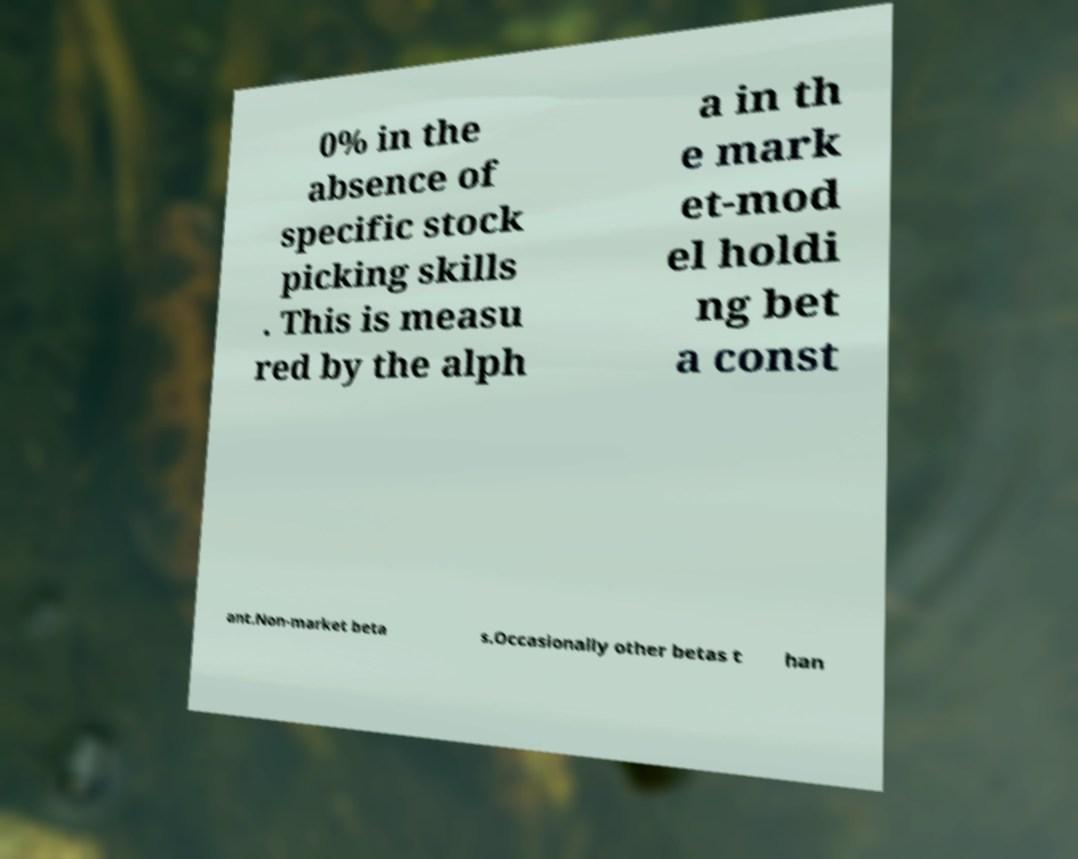Could you assist in decoding the text presented in this image and type it out clearly? 0% in the absence of specific stock picking skills . This is measu red by the alph a in th e mark et-mod el holdi ng bet a const ant.Non-market beta s.Occasionally other betas t han 